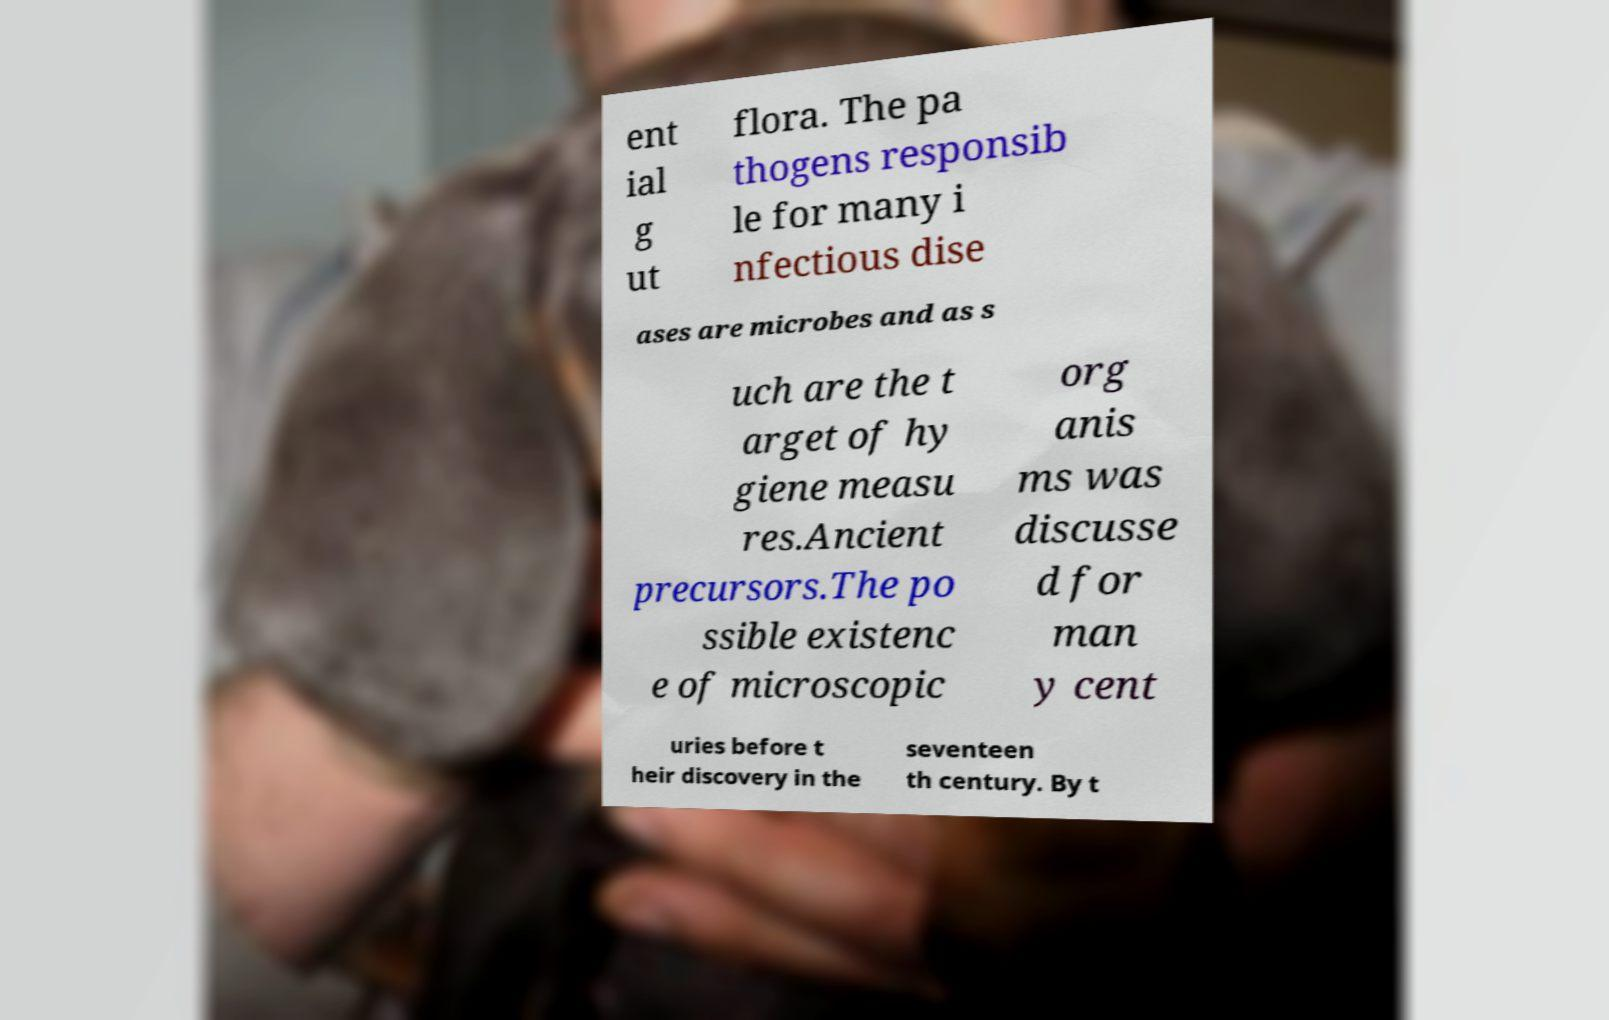Could you extract and type out the text from this image? ent ial g ut flora. The pa thogens responsib le for many i nfectious dise ases are microbes and as s uch are the t arget of hy giene measu res.Ancient precursors.The po ssible existenc e of microscopic org anis ms was discusse d for man y cent uries before t heir discovery in the seventeen th century. By t 